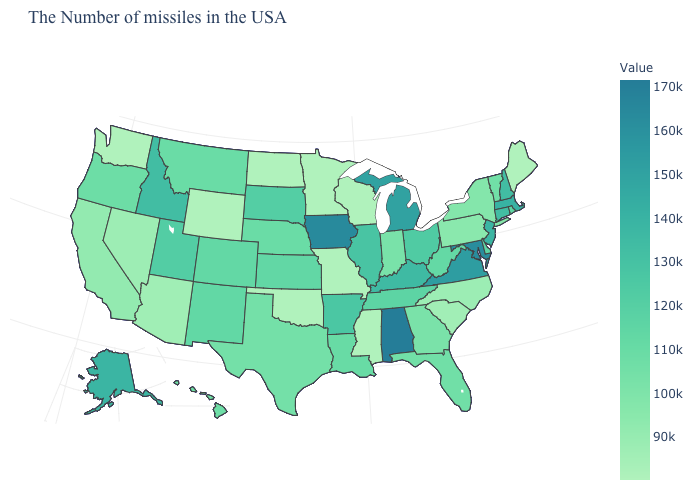Is the legend a continuous bar?
Give a very brief answer. Yes. 